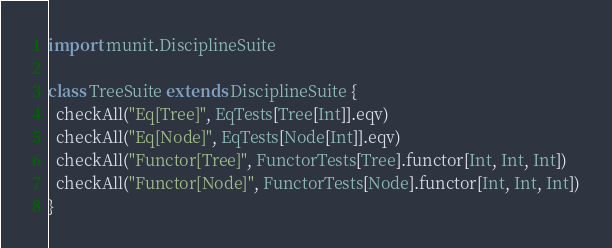<code> <loc_0><loc_0><loc_500><loc_500><_Scala_>import munit.DisciplineSuite

class TreeSuite extends DisciplineSuite {
  checkAll("Eq[Tree]", EqTests[Tree[Int]].eqv)
  checkAll("Eq[Node]", EqTests[Node[Int]].eqv)
  checkAll("Functor[Tree]", FunctorTests[Tree].functor[Int, Int, Int])
  checkAll("Functor[Node]", FunctorTests[Node].functor[Int, Int, Int])
}
</code> 